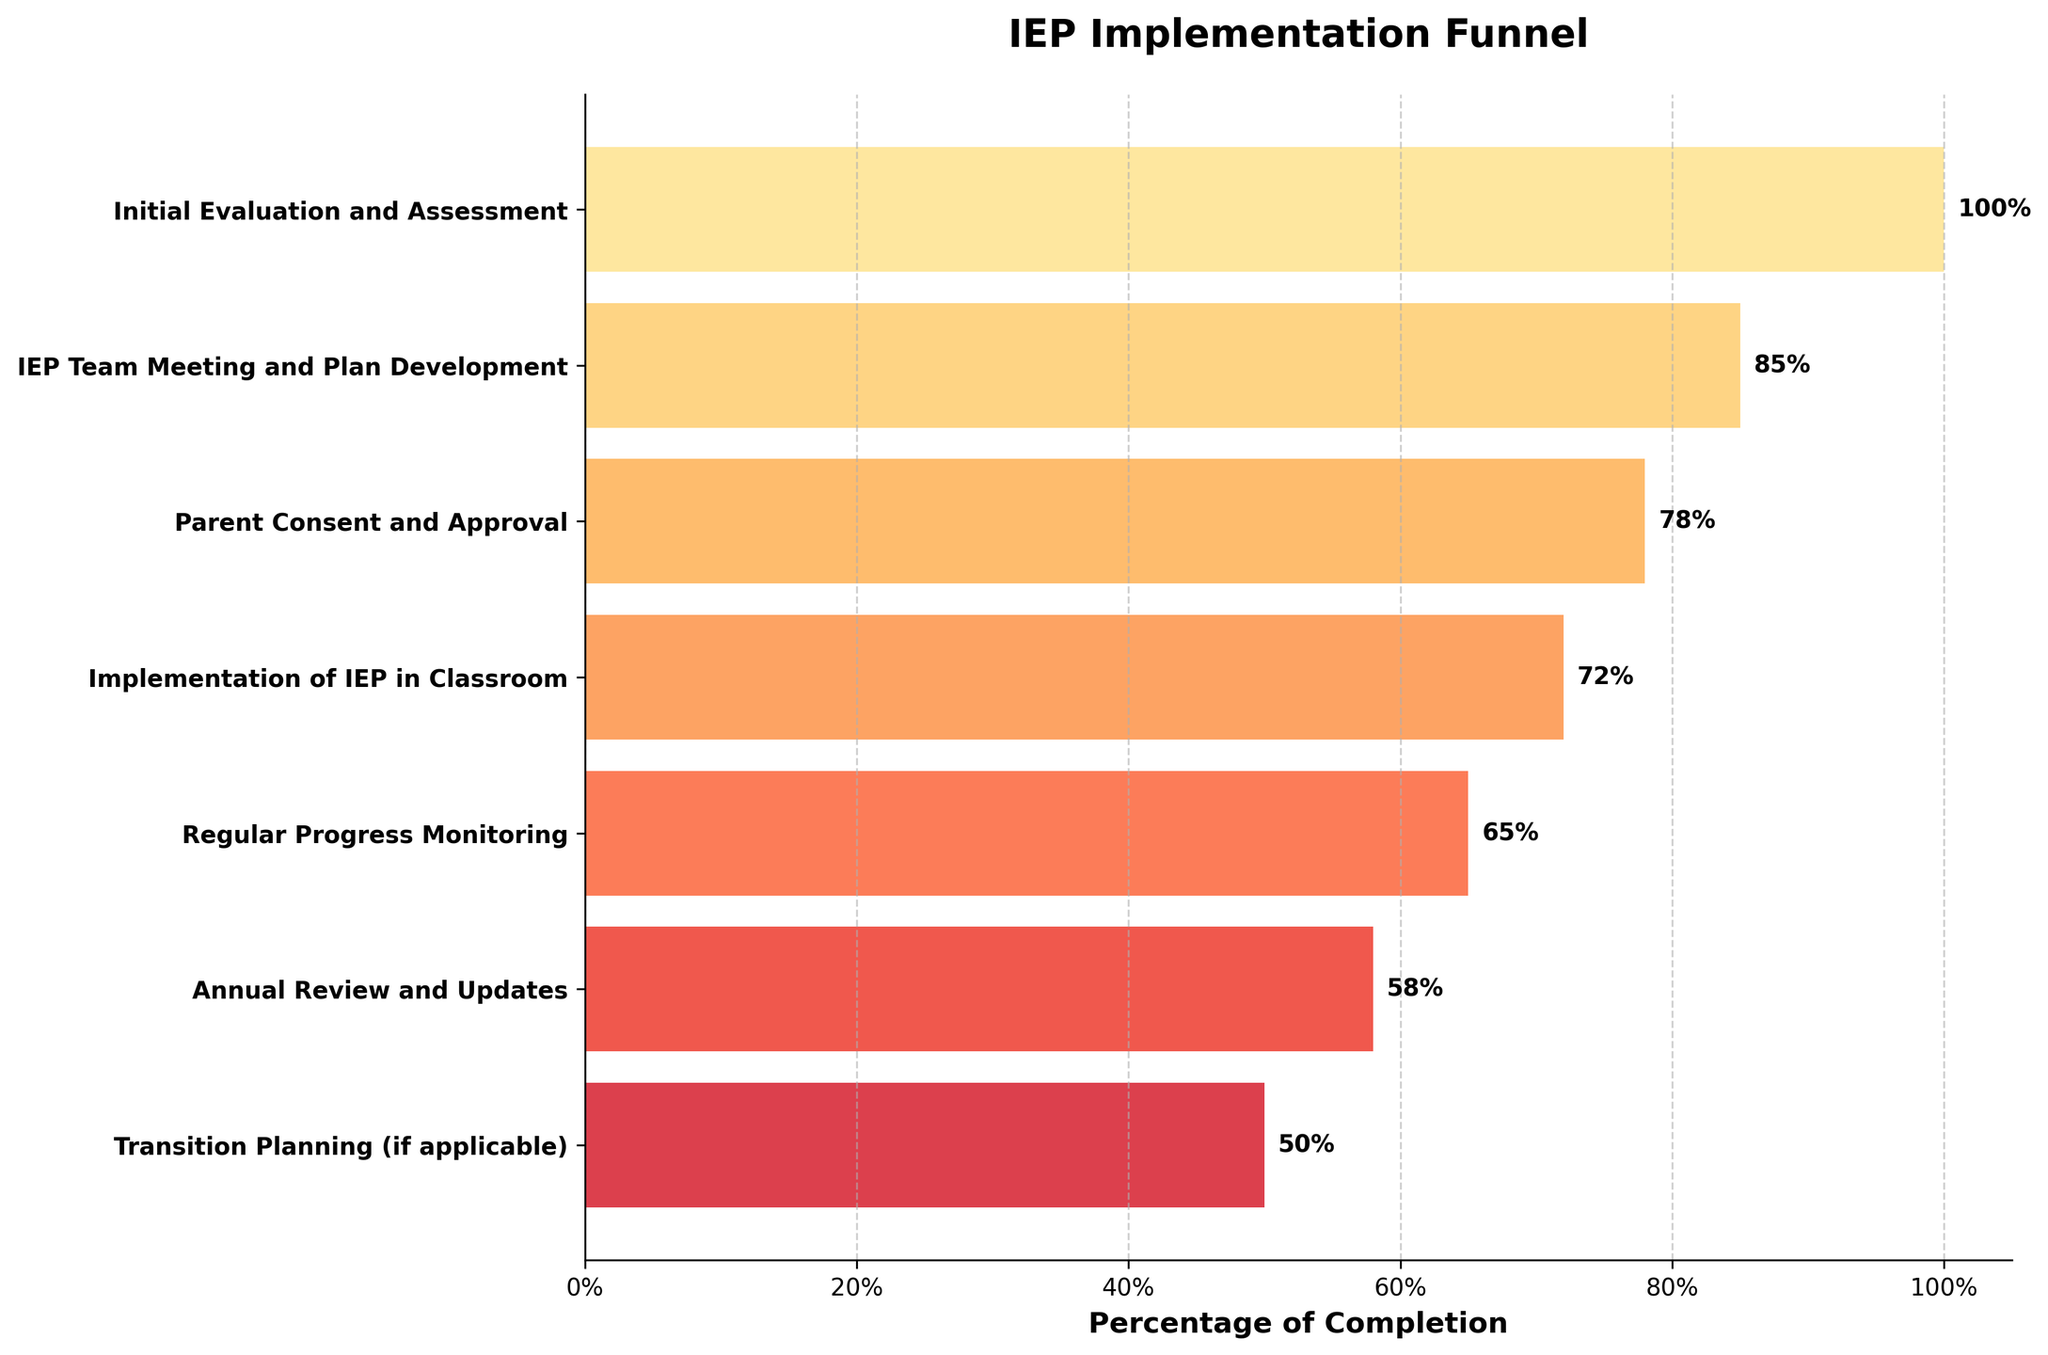What is the title of the funnel chart? The title of the chart is displayed prominently at the top. It reads "IEP Implementation Funnel."
Answer: IEP Implementation Funnel What is the percentage of successful completion at the "Parent Consent and Approval" phase? The percentage for "Parent Consent and Approval" can be found directly next to this label in the funnel chart. It reads 78%.
Answer: 78% Which phase has the lowest percentage of successful completion? The phase with the lowest percentage of successful completion can be identified as the smallest bar in the funnel. This is "Transition Planning (if applicable)" with 50%.
Answer: Transition Planning (if applicable) What is the percentage difference between the "Initial Evaluation and Assessment" phase and the "Annual Review and Updates" phase? The percentage for "Initial Evaluation and Assessment" is 100%, and for "Annual Review and Updates" it is 58%. Subtracting the latter from the former gives 100% - 58% = 42%.
Answer: 42% How many phases are shown in the funnel chart? By counting the number of bars, or by looking at the labels on the y-axis, you can see there are seven phases listed in the funnel chart.
Answer: 7 What can you infer about the overall trend of completion percentages as the phases progress? The funnel chart shows a downward trend with each subsequent phase having a reduced percentage of successful completion compared to the previous one, indicating a gradual drop-off throughout the IEP implementation process.
Answer: Downward trend What percentage of successful completion is achieved by the time "Implementation of IEP in Classroom" is reached? The specific percentage for "Implementation of IEP in Classroom" can be seen directly next to the label in the chart, which is 72%.
Answer: 72% How many phases have a percentage of successful completion higher than 70%? By identifying the phases with percentages higher than 70%, we find "Initial Evaluation and Assessment" (100%), "IEP Team Meeting and Plan Development" (85%), "Parent Consent and Approval" (78%), and "Implementation of IEP in Classroom" (72%). There are four such phases.
Answer: 4 Compare the completion percentage of "Regular Progress Monitoring" to "Parent Consent and Approval". Which one is higher and by how much? "Regular Progress Monitoring" has 65% while "Parent Consent and Approval" has 78%. The difference is 78% - 65% = 13%. "Parent Consent and Approval" is higher by 13%.
Answer: Parent Consent and Approval by 13% 